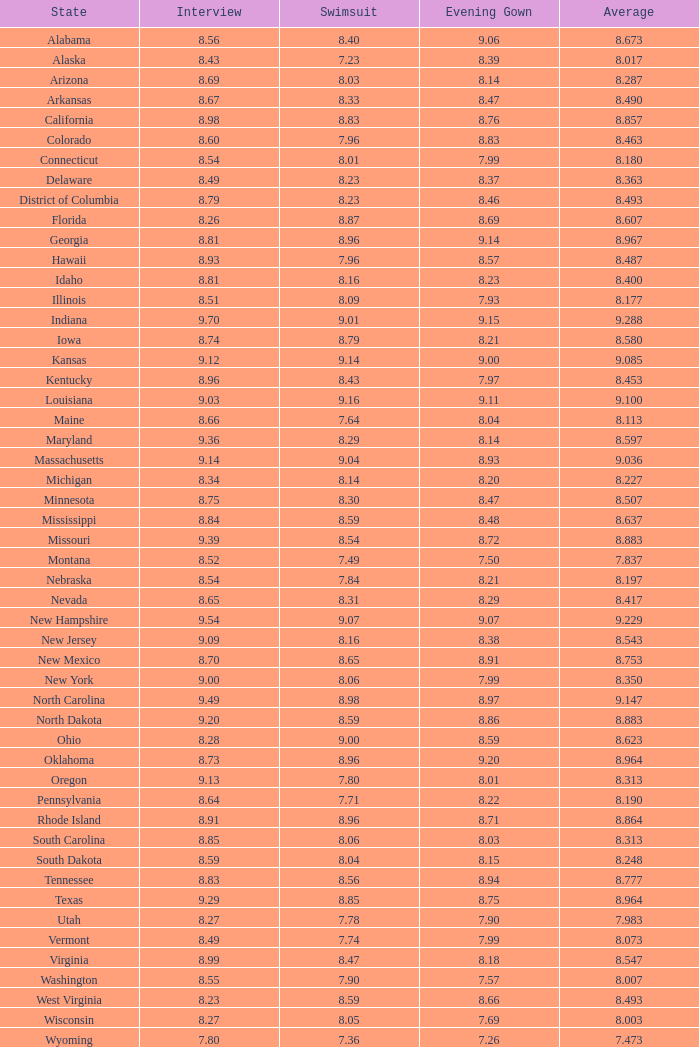21 and mean of 1.0. 